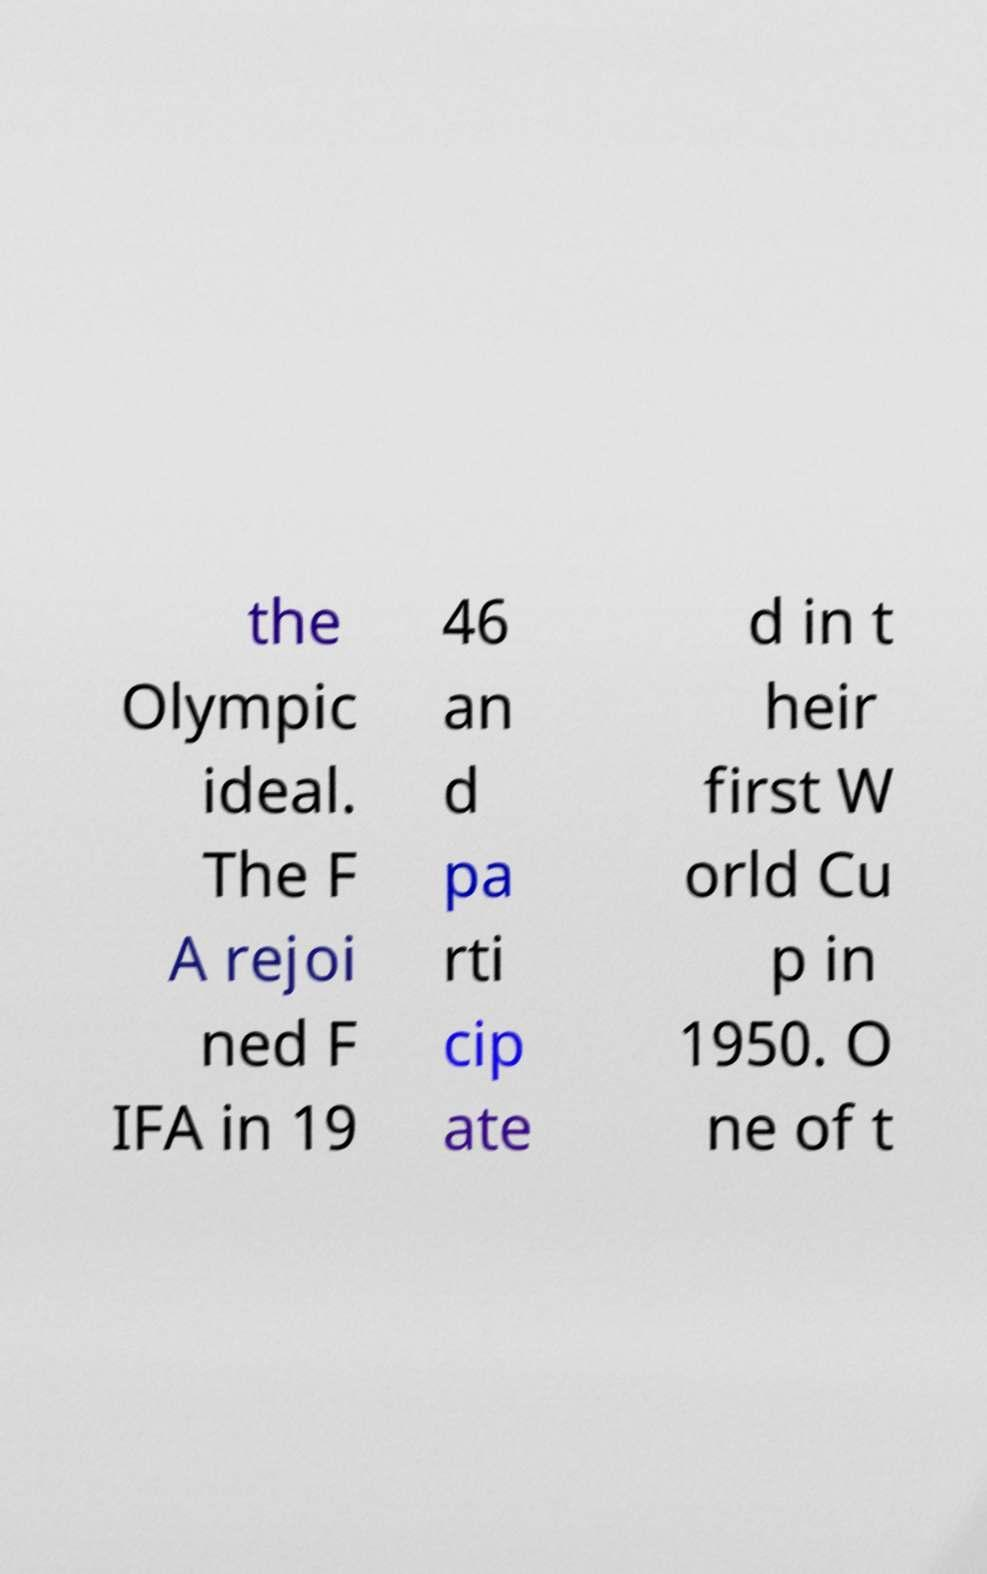I need the written content from this picture converted into text. Can you do that? the Olympic ideal. The F A rejoi ned F IFA in 19 46 an d pa rti cip ate d in t heir first W orld Cu p in 1950. O ne of t 